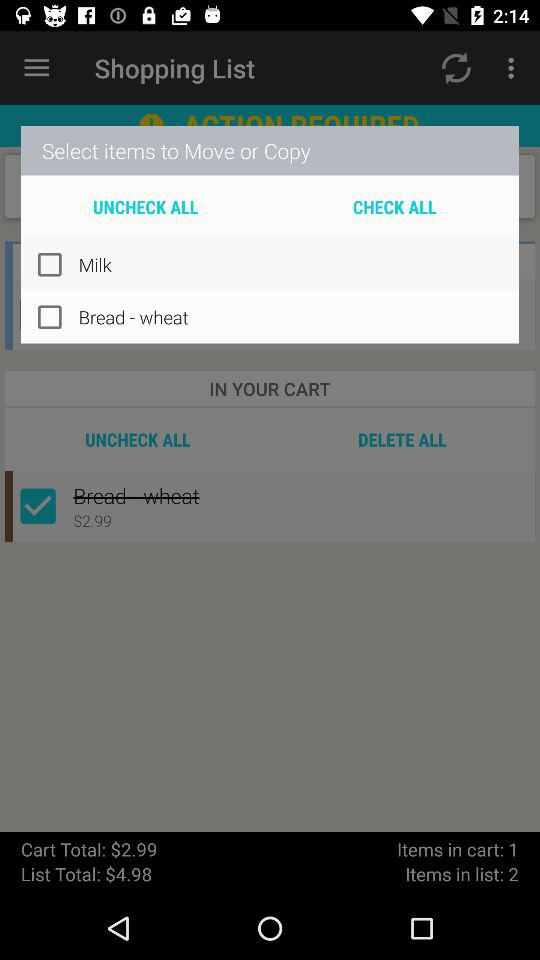What is the total list amount? The total list amount is $4.98. 